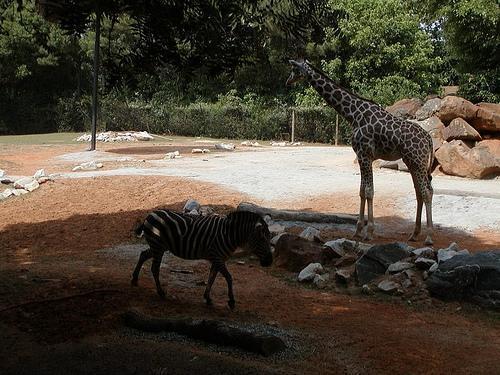How many animals are seen?
Give a very brief answer. 2. 